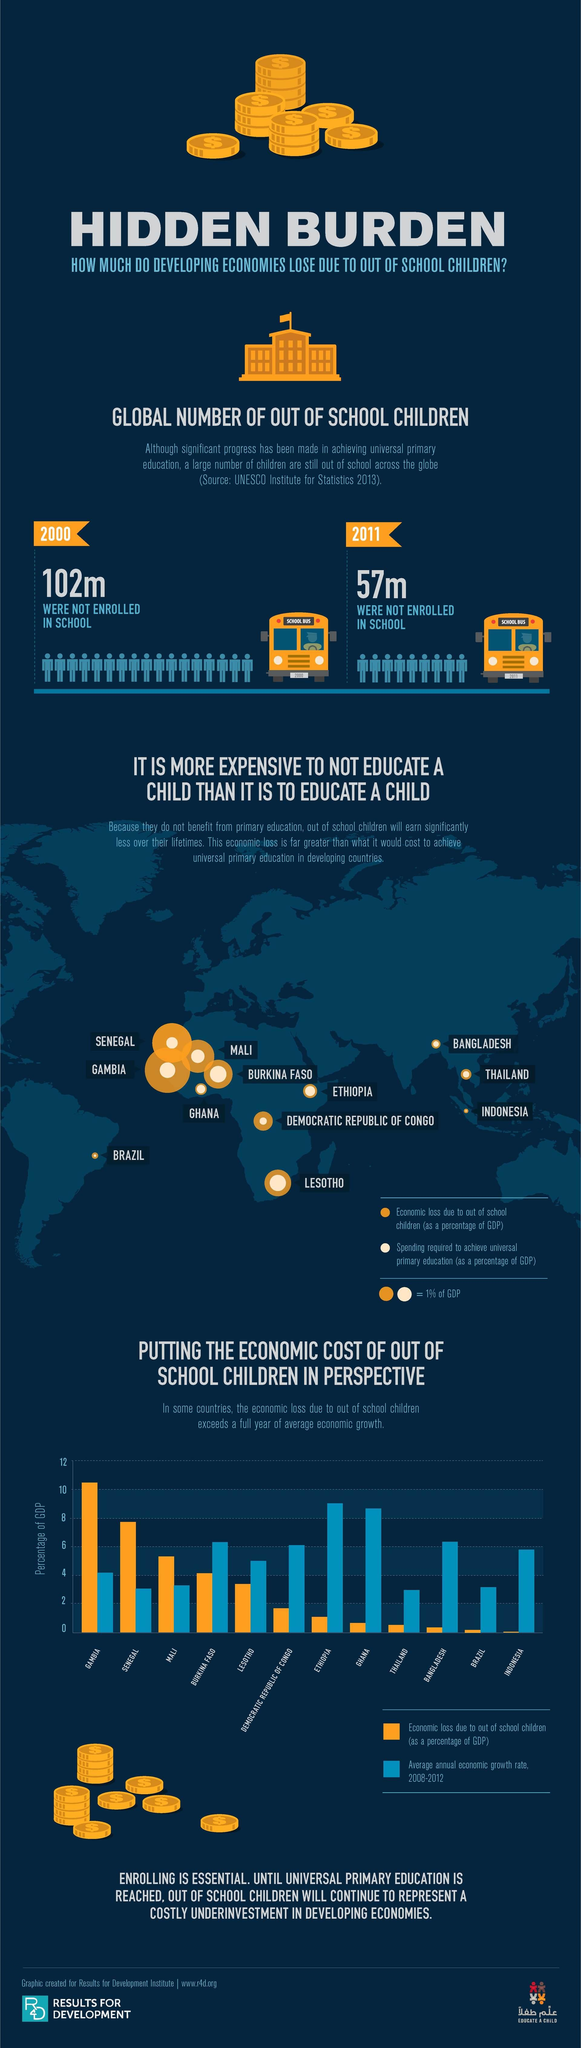Highlight a few significant elements in this photo. It is estimated that in 2000, a total of 102 million children were not enrolled in school. In 2011, a total of 57 children were not enrolled in the school. 